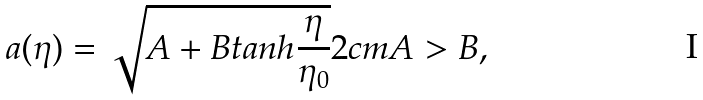Convert formula to latex. <formula><loc_0><loc_0><loc_500><loc_500>a ( \eta ) = \sqrt { A + B t a n h \frac { \eta } { \eta _ { 0 } } } 2 c m A > B ,</formula> 